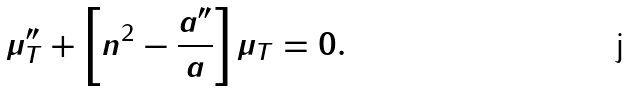Convert formula to latex. <formula><loc_0><loc_0><loc_500><loc_500>\mu _ { T } ^ { \prime \prime } + \left [ n ^ { 2 } - \frac { a ^ { \prime \prime } } { a } \right ] \mu _ { T } = 0 .</formula> 